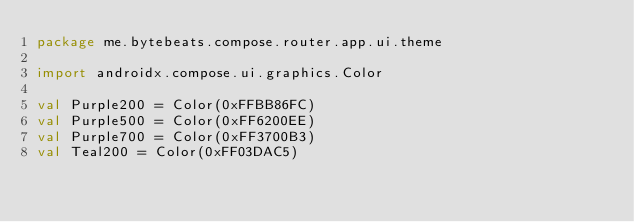Convert code to text. <code><loc_0><loc_0><loc_500><loc_500><_Kotlin_>package me.bytebeats.compose.router.app.ui.theme

import androidx.compose.ui.graphics.Color

val Purple200 = Color(0xFFBB86FC)
val Purple500 = Color(0xFF6200EE)
val Purple700 = Color(0xFF3700B3)
val Teal200 = Color(0xFF03DAC5)</code> 